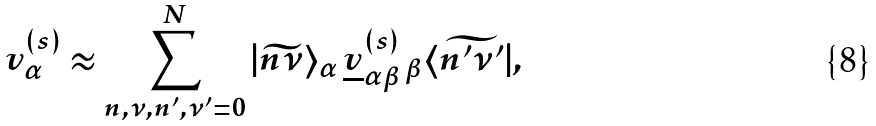Convert formula to latex. <formula><loc_0><loc_0><loc_500><loc_500>v _ { \alpha } ^ { ( s ) } \approx \sum _ { n , \nu , n ^ { \prime } , \nu ^ { \prime } = 0 } ^ { N } | \widetilde { n \nu } \rangle _ { \alpha } \, \underline { v } _ { \alpha \beta } ^ { ( s ) } \, _ { \beta } \langle \widetilde { n ^ { \prime } \nu ^ { \prime } } | ,</formula> 